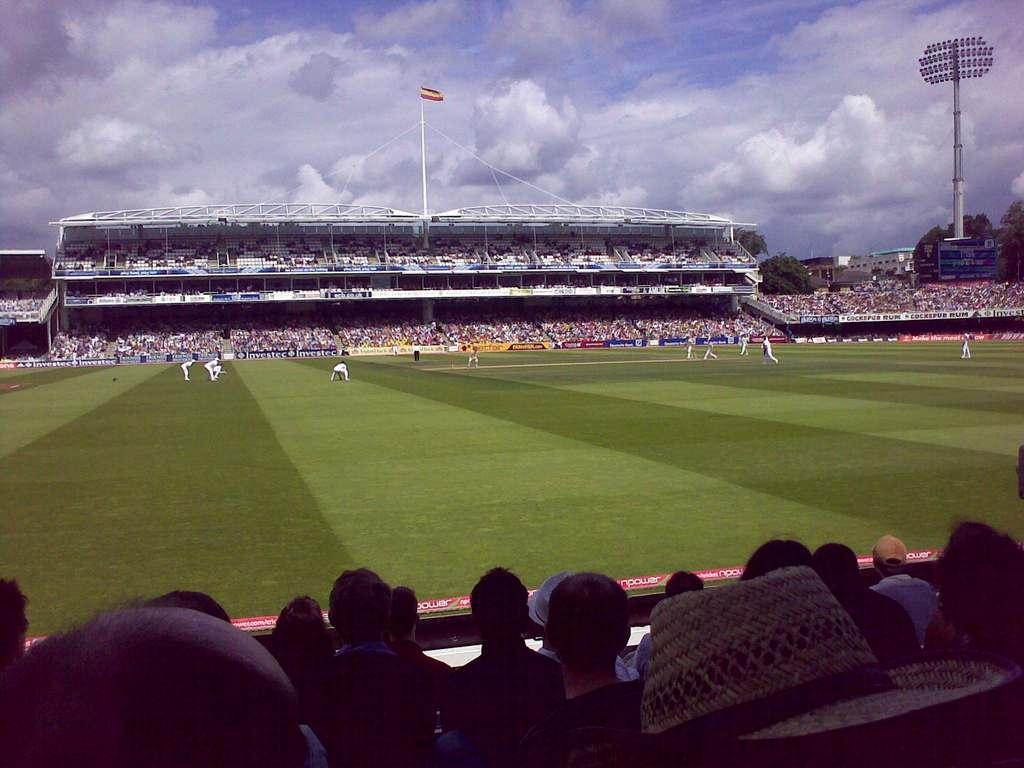Can you describe this image briefly? In this image, we can see the stadium. We can see the ground covered with grass. We can see the fence. There are a few people. We can see a flag and a pole with some lights. We can see some trees, buildings. We can see the sky with clouds. 